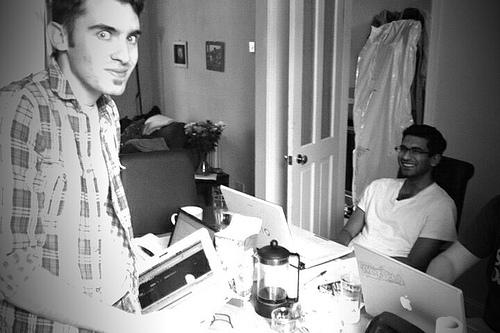How does the seated man think the standing man is acting? Please explain your reasoning. funny. The man seated is visibly smiling while looking at the other person. when people are smiling while looking at something that thing is often funny. 